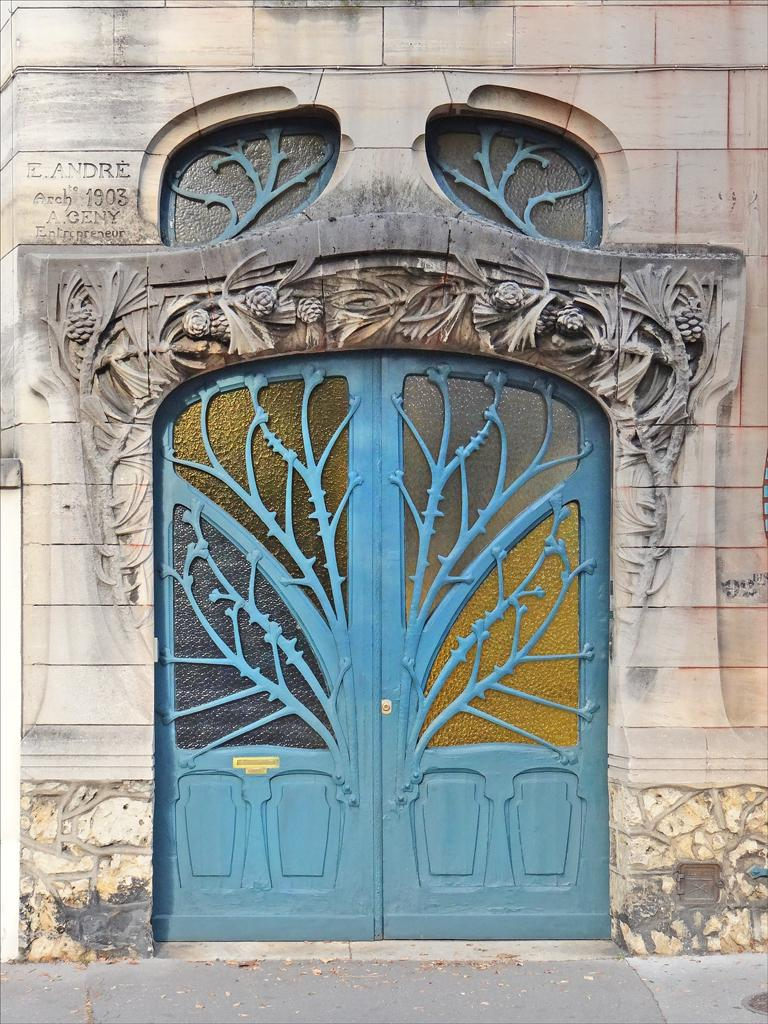What type of structure is present in the image? There is a building in the image. What feature of the building is mentioned in the facts? The building has a door and a design on the wall. Are there any words or letters on the building? Yes, there is text on the wall of the building. Which actor is standing near the building in the image? There is no actor present in the image; it only features a building with a door, a design on the wall, and text. 